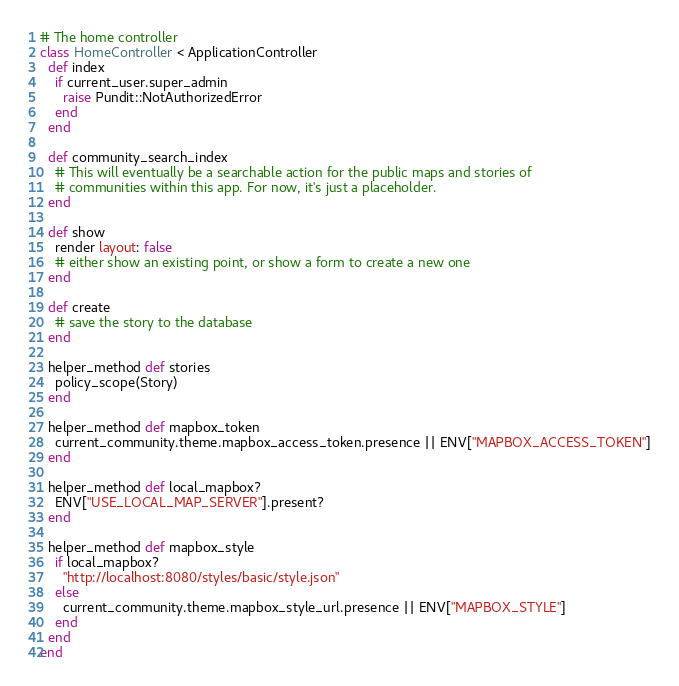<code> <loc_0><loc_0><loc_500><loc_500><_Ruby_># The home controller
class HomeController < ApplicationController
  def index
    if current_user.super_admin
      raise Pundit::NotAuthorizedError
    end
  end

  def community_search_index
    # This will eventually be a searchable action for the public maps and stories of
    # communities within this app. For now, it's just a placeholder.
  end

  def show
    render layout: false
    # either show an existing point, or show a form to create a new one
  end

  def create
    # save the story to the database
  end

  helper_method def stories
    policy_scope(Story)
  end

  helper_method def mapbox_token
    current_community.theme.mapbox_access_token.presence || ENV["MAPBOX_ACCESS_TOKEN"]
  end

  helper_method def local_mapbox?
    ENV["USE_LOCAL_MAP_SERVER"].present?
  end

  helper_method def mapbox_style
    if local_mapbox?
      "http://localhost:8080/styles/basic/style.json"
    else
      current_community.theme.mapbox_style_url.presence || ENV["MAPBOX_STYLE"]
    end
  end
end
</code> 